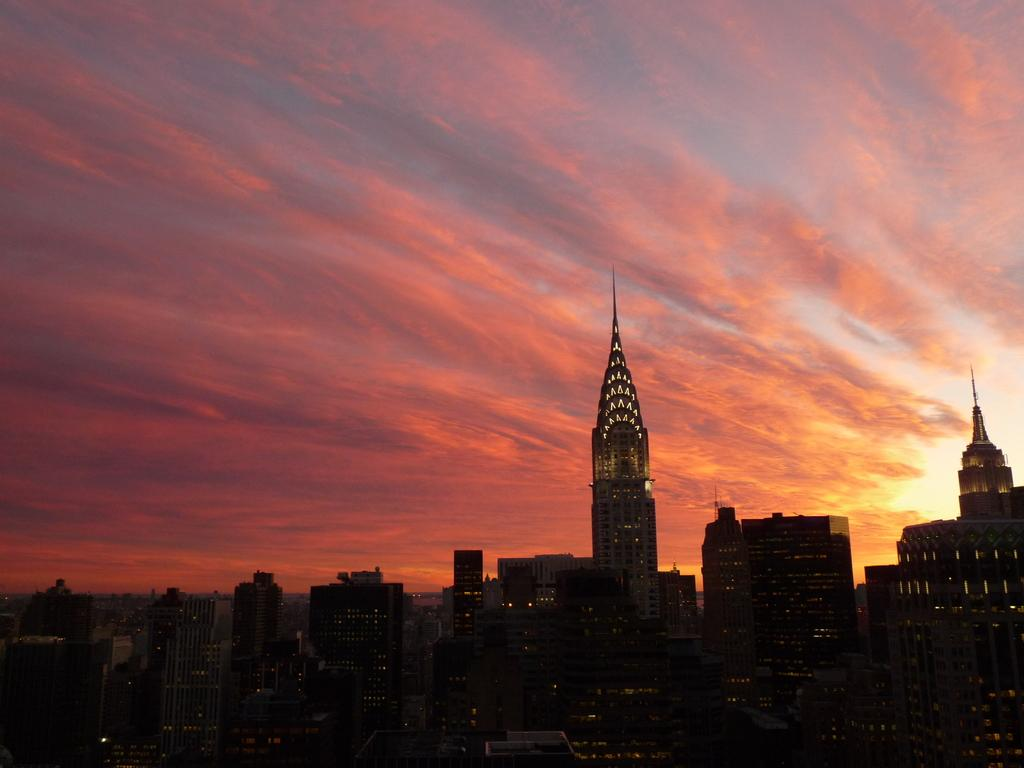What is the main subject in the foreground of the image? There is a city in the foreground of the image. What types of structures can be seen in the city? The city includes buildings and skyscrapers. What can be seen in the background of the image? The sky is visible in the image. What is the condition of the sky in the image? There are clouds in the sky. Can you tell me how many grains of rice are visible in the image? There are no grains of rice present in the image; it features a city with buildings and skyscrapers. What type of recess can be seen in the image? There is no recess present in the image; it features a city with buildings and skyscrapers. 